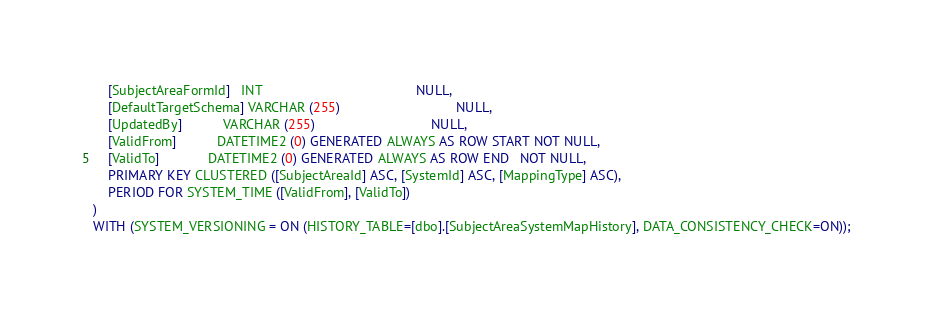Convert code to text. <code><loc_0><loc_0><loc_500><loc_500><_SQL_>    [SubjectAreaFormId]   INT                                         NULL,
    [DefaultTargetSchema] VARCHAR (255)                               NULL,
    [UpdatedBy]           VARCHAR (255)                               NULL,
    [ValidFrom]           DATETIME2 (0) GENERATED ALWAYS AS ROW START NOT NULL,
    [ValidTo]             DATETIME2 (0) GENERATED ALWAYS AS ROW END   NOT NULL,
    PRIMARY KEY CLUSTERED ([SubjectAreaId] ASC, [SystemId] ASC, [MappingType] ASC),
    PERIOD FOR SYSTEM_TIME ([ValidFrom], [ValidTo])
)
WITH (SYSTEM_VERSIONING = ON (HISTORY_TABLE=[dbo].[SubjectAreaSystemMapHistory], DATA_CONSISTENCY_CHECK=ON));

</code> 